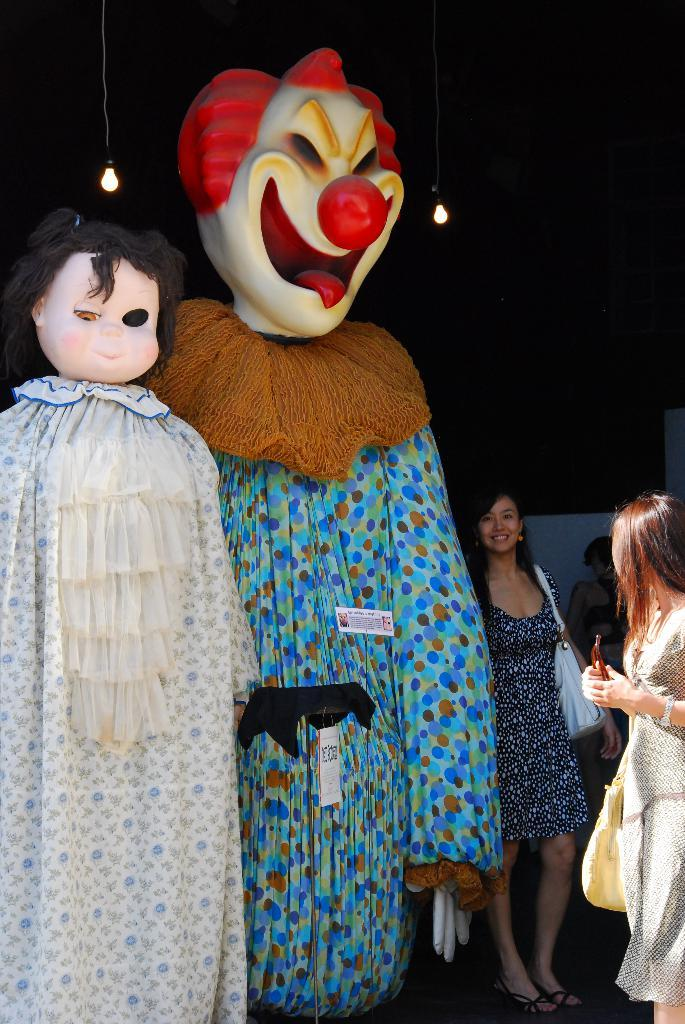What can be seen in the image in terms of illustrations? There are two cartoon depictions in the image. Are there any people present in the image? Yes, there are people standing beside the cartoon depictions. What type of lighting is present in the image? There are lamps hanging at the top of the image. Can you tell me how many ducks are sitting on the bookshelves in the image? There are no ducks present in the image, and no bookshelves are visible. 